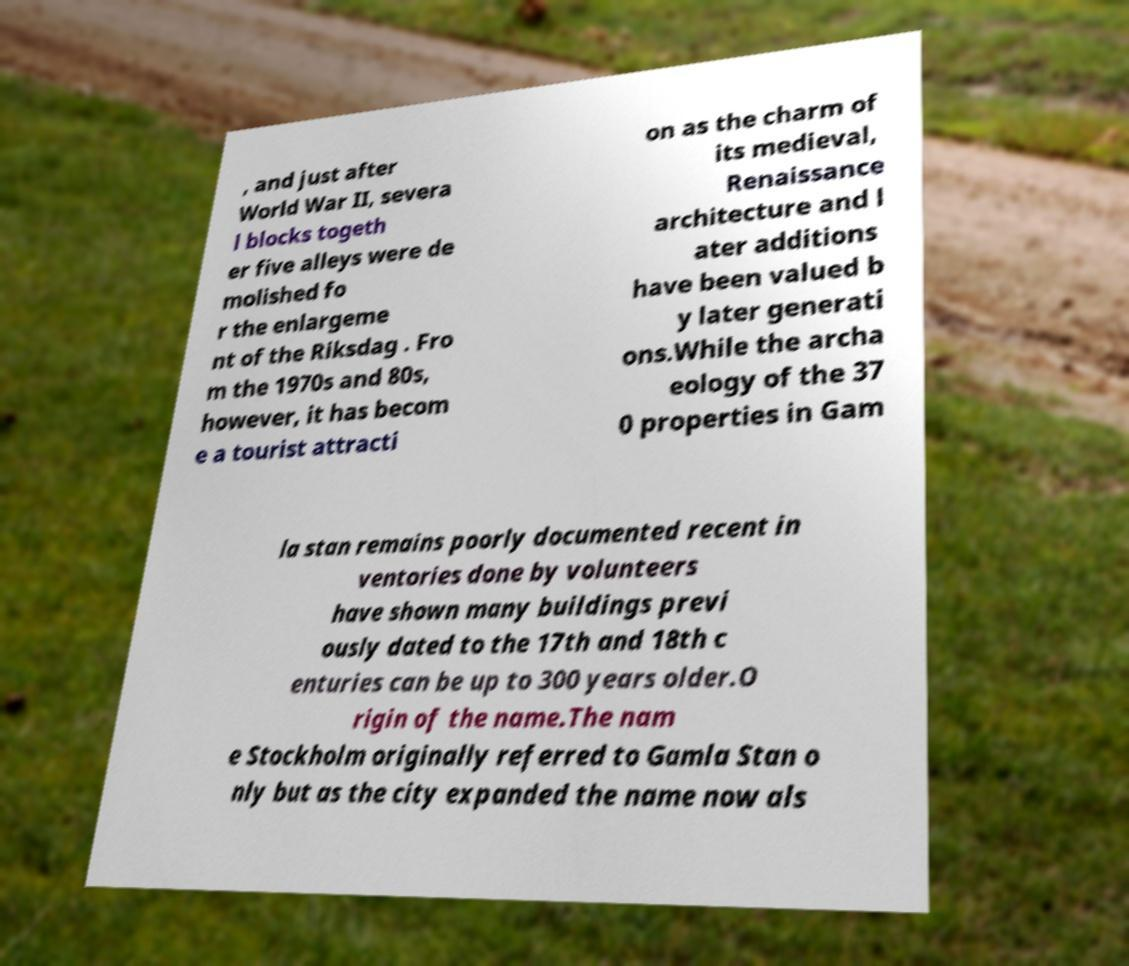Can you accurately transcribe the text from the provided image for me? , and just after World War II, severa l blocks togeth er five alleys were de molished fo r the enlargeme nt of the Riksdag . Fro m the 1970s and 80s, however, it has becom e a tourist attracti on as the charm of its medieval, Renaissance architecture and l ater additions have been valued b y later generati ons.While the archa eology of the 37 0 properties in Gam la stan remains poorly documented recent in ventories done by volunteers have shown many buildings previ ously dated to the 17th and 18th c enturies can be up to 300 years older.O rigin of the name.The nam e Stockholm originally referred to Gamla Stan o nly but as the city expanded the name now als 